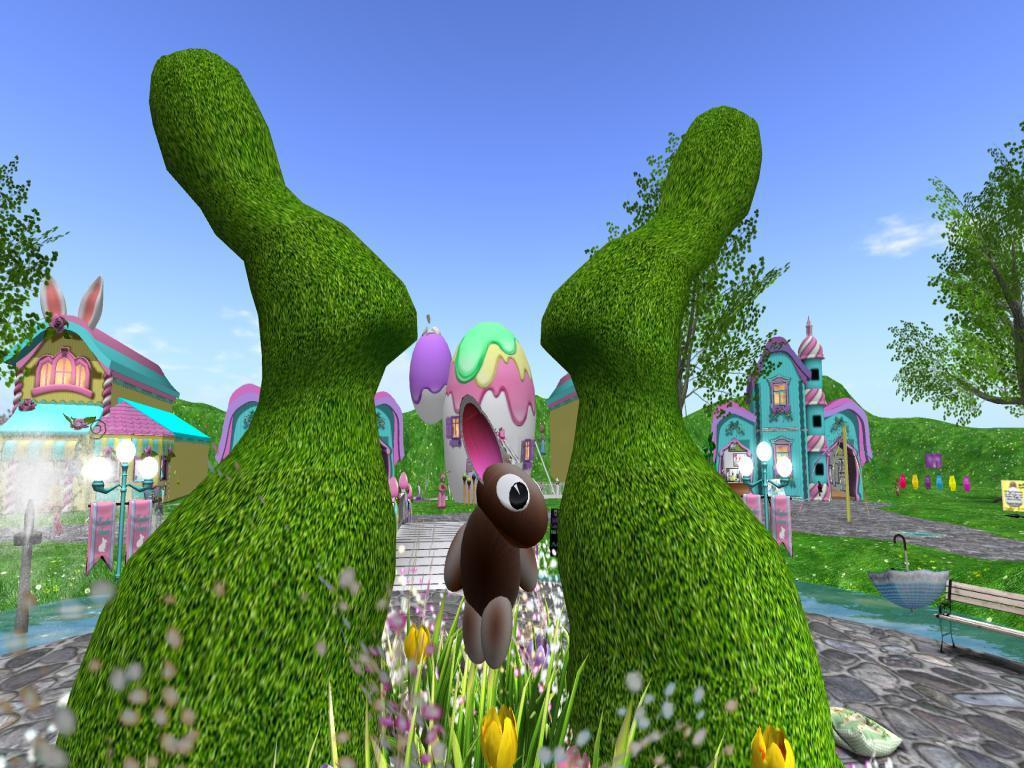What type of picture is in the image? The image contains an animated picture. What can be seen inside the animated picture? There are doll houses in the animated picture. What kind of environment is depicted in the animated picture? There is greenery in the animated picture. What type of juice is being served in the doll houses in the image? There is no juice being served in the doll houses in the image, as the image only contains an animated picture with doll houses and greenery. 